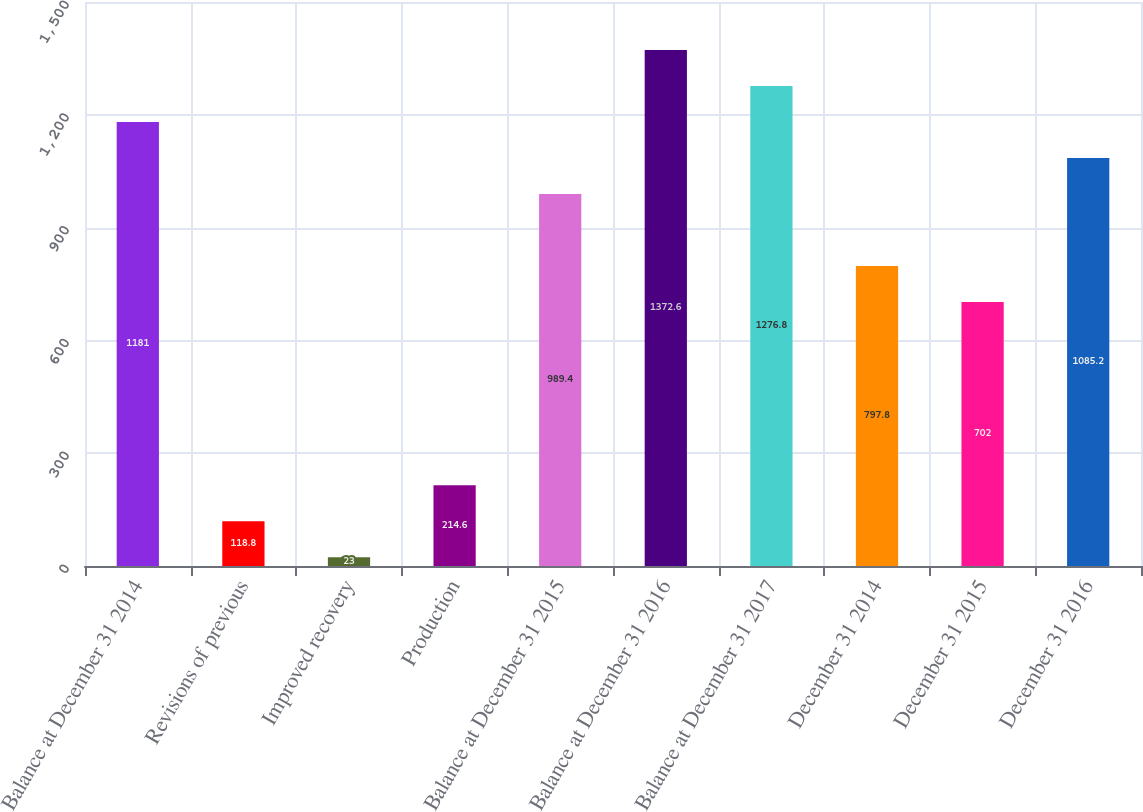Convert chart to OTSL. <chart><loc_0><loc_0><loc_500><loc_500><bar_chart><fcel>Balance at December 31 2014<fcel>Revisions of previous<fcel>Improved recovery<fcel>Production<fcel>Balance at December 31 2015<fcel>Balance at December 31 2016<fcel>Balance at December 31 2017<fcel>December 31 2014<fcel>December 31 2015<fcel>December 31 2016<nl><fcel>1181<fcel>118.8<fcel>23<fcel>214.6<fcel>989.4<fcel>1372.6<fcel>1276.8<fcel>797.8<fcel>702<fcel>1085.2<nl></chart> 